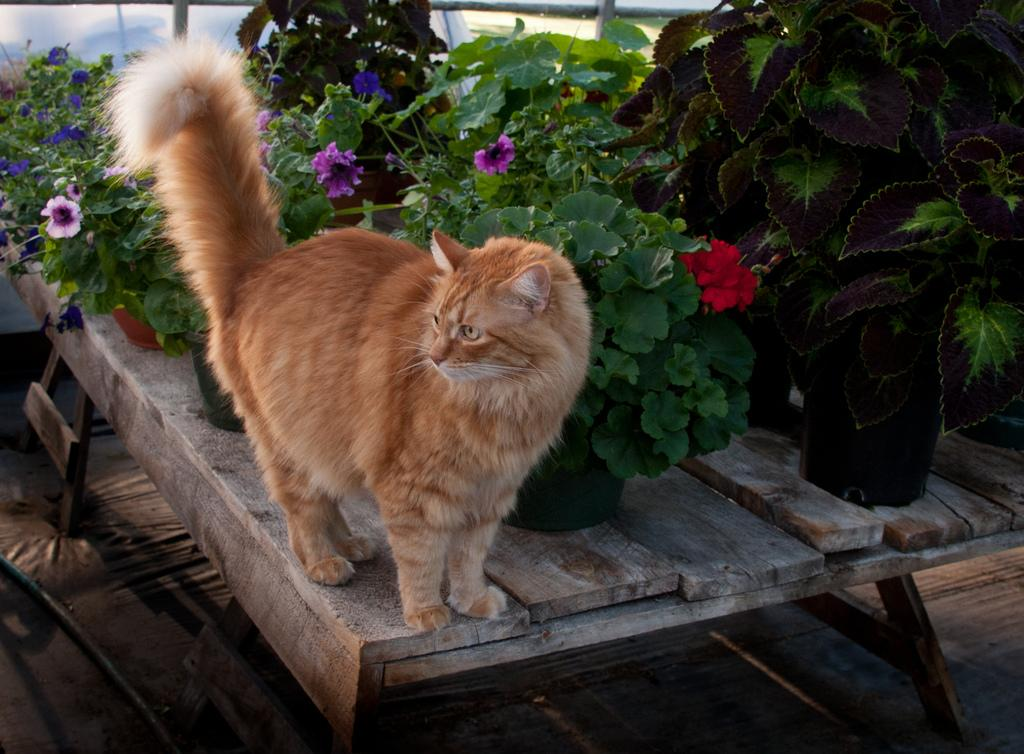What type of animal is on the table in the image? There is a cat on the table in the image. What else can be seen on the table besides the cat? There are many flower pots on the table. How many buildings can be seen in the image? There are no buildings visible in the image; it features a cat and flower pots on a table. Is the cat sleeping in the image? The image does not provide information about the cat's state of sleep, so it cannot be determined from the image. 